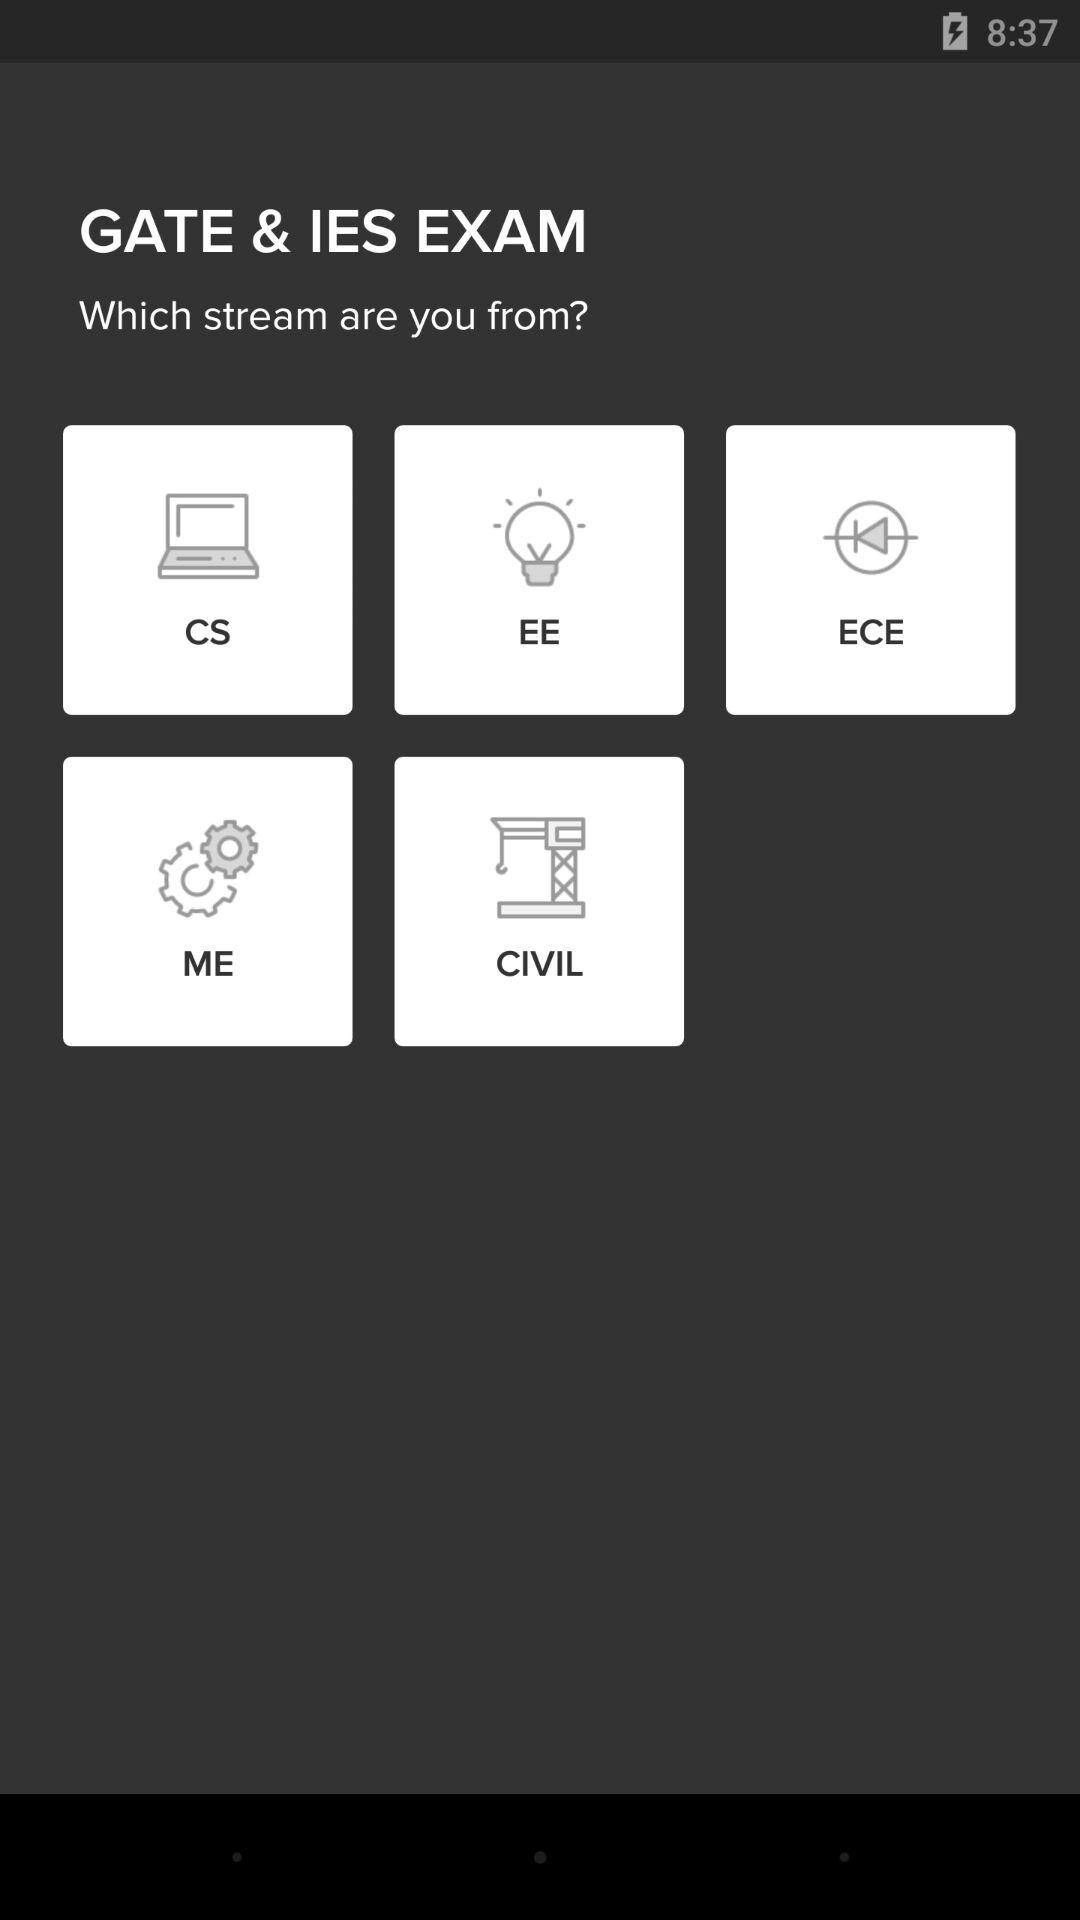How many stream options are there?
When the provided information is insufficient, respond with <no answer>. <no answer> 